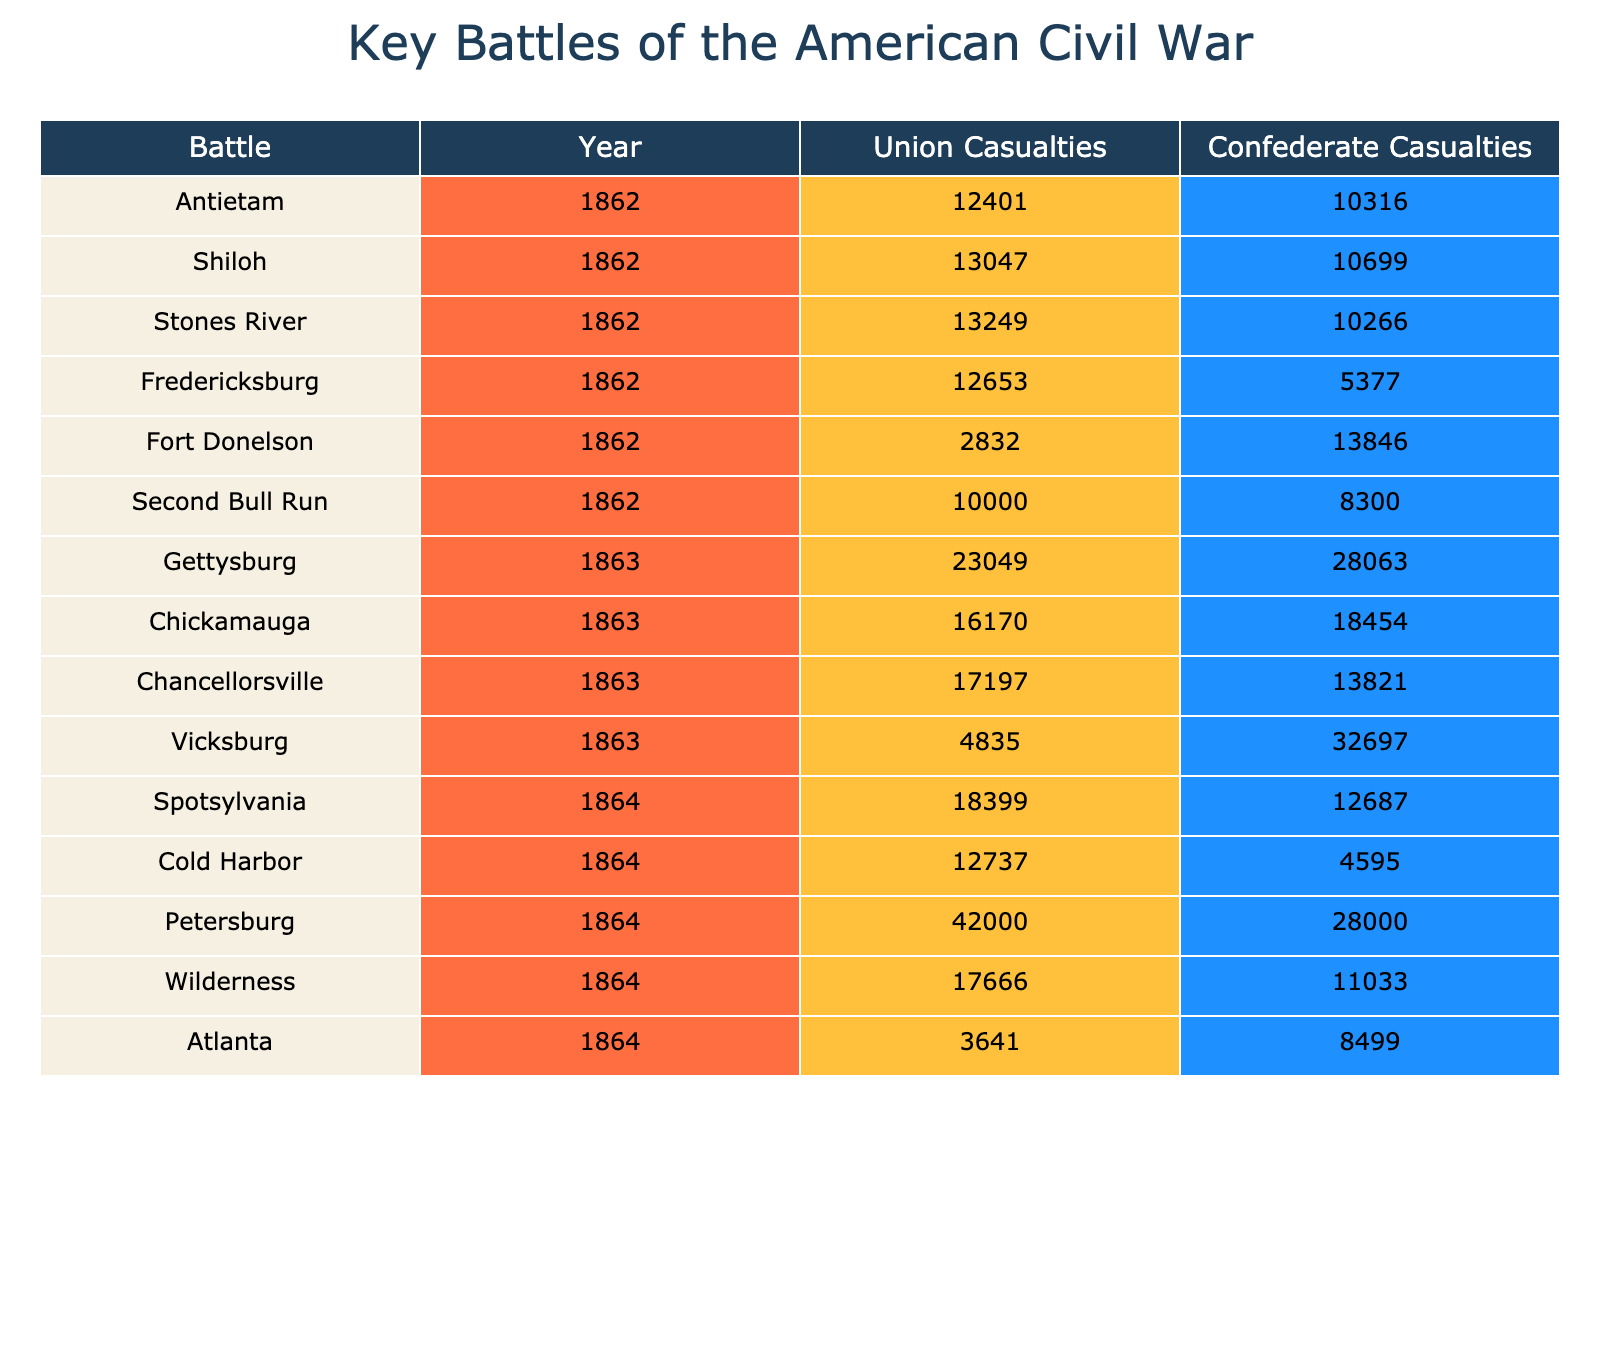What was the total number of Union casualties in the Battle of Gettysburg? The table shows the Union casualties for the Battle of Gettysburg as 23,049.
Answer: 23,049 Which battle had the highest Confederate casualties? By looking at the Confederate casualties for each battle, the Battle of Chickamauga has the highest count at 18,454.
Answer: 18,454 What is the difference in Union casualties between the Battles of Antietam and Shiloh? For Antietam, Union casualties are 12,401, and for Shiloh, they are 13,047. The difference is 13,047 - 12,401 = 646.
Answer: 646 Was the Union casualty count higher in the Battle of Chancellorsville than in the Battle of Vicksburg? For Chancellorsville, Union casualties are 17,197, and for Vicksburg, they are 4,835. Since 17,197 is greater than 4,835, the answer is yes.
Answer: Yes What is the average number of Union casualties across all battles listed? To find the average, first sum all the Union casualties: 23,049 + 12,401 + 16,170 + 17,197 + 13,047 + 13,249 + 18,399 + 12,737 + 12,653 + 42,000 + 4,835 + 17,666 + 3,641 + 2,832 + 10,000 = 302,180. There are 15 battles, so the average is 302,180 / 15 = 20,145.33.
Answer: 20,145 In which year did the Battle of Fredericksburg take place? The table indicates that the Battle of Fredericksburg occurred in the year 1862.
Answer: 1862 How many total casualties (Union and Confederate) were reported in the Battle of Petersburg? For Petersburg, Union casualties are 42,000 and Confederate casualties are 28,000. The total is 42,000 + 28,000 = 70,000.
Answer: 70,000 Was the average Confederate casualty count across all battles greater than 15,000? First, sum all Confederate casualties: 28,063 + 10,316 + 18,454 + 13,821 + 10,699 + 10,266 + 12,687 + 4,595 + 5,377 + 28,000 + 32,697 + 11,033 + 8,499 + 13,846 + 8,300 = 298,364. There are 15 battles, so the average is 298,364 / 15 = 19,890.93, which is greater than 15,000.
Answer: Yes What was the total Union casualty count in 1863? The battles in 1863 included Gettysburg (23,049), Chickamauga (16,170), Chancellorsville (17,197), and Vicksburg (4,835). Summing these gives 23,049 + 16,170 + 17,197 + 4,835 = 61,251.
Answer: 61,251 Which battle had the lowest Union casualties and what were they? The battle with the lowest Union casualties is Fort Donelson, with 2,832 casualties.
Answer: 2,832 What is the total difference in casualties (Union and Confederate) in the Battle of Cold Harbor? For Cold Harbor, Union casualties are 12,737 and Confederate casualties are 4,595. The difference is 12,737 - 4,595 = 8,142.
Answer: 8,142 